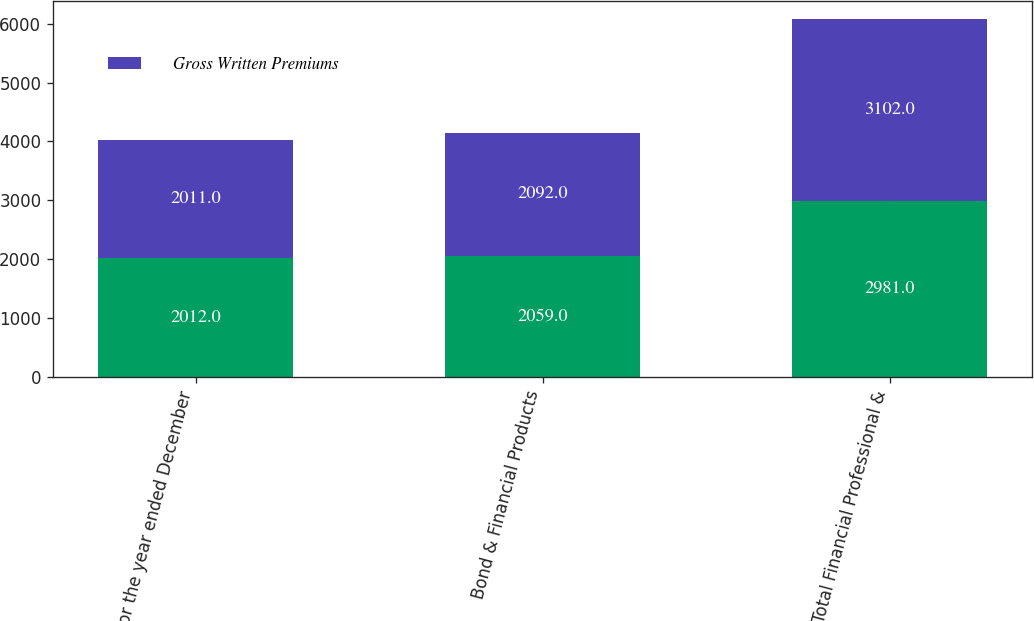<chart> <loc_0><loc_0><loc_500><loc_500><stacked_bar_chart><ecel><fcel>(for the year ended December<fcel>Bond & Financial Products<fcel>Total Financial Professional &<nl><fcel>nan<fcel>2012<fcel>2059<fcel>2981<nl><fcel>Gross Written Premiums<fcel>2011<fcel>2092<fcel>3102<nl></chart> 